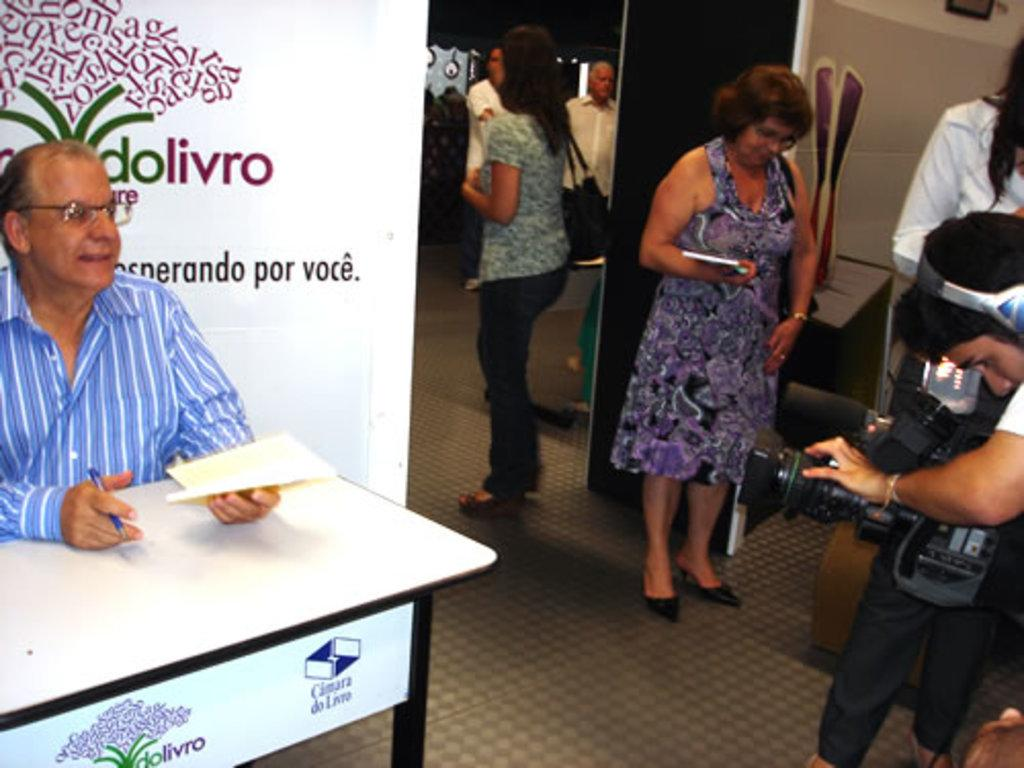What are the people in the image doing? The people in the image are standing. Can you describe the position of one of the men in the image? There is a man sitting in the image. What is one of the men holding in the image? A man is holding a camera in the image. What type of stitch is being used to repair the engine in the image? There is no engine or stitching present in the image; it features people standing and a man sitting with a camera. 